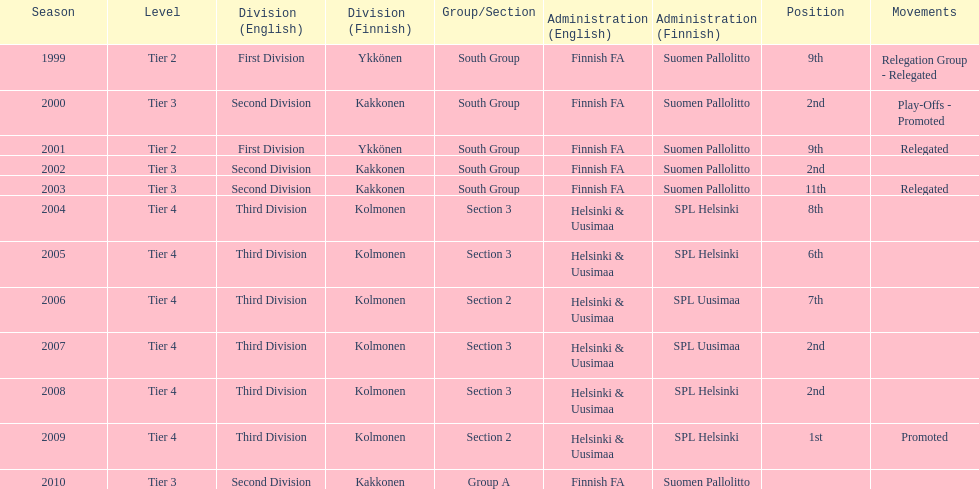Which administration has the least amount of division? Helsinki & Uusimaa (SPL Helsinki). Could you parse the entire table as a dict? {'header': ['Season', 'Level', 'Division (English)', 'Division (Finnish)', 'Group/Section', 'Administration (English)', 'Administration (Finnish)', 'Position', 'Movements'], 'rows': [['1999', 'Tier 2', 'First Division', 'Ykkönen', 'South Group', 'Finnish FA', 'Suomen Pallolitto', '9th', 'Relegation Group - Relegated'], ['2000', 'Tier 3', 'Second Division', 'Kakkonen', 'South Group', 'Finnish FA', 'Suomen Pallolitto', '2nd', 'Play-Offs - Promoted'], ['2001', 'Tier 2', 'First Division', 'Ykkönen', 'South Group', 'Finnish FA', 'Suomen Pallolitto', '9th', 'Relegated'], ['2002', 'Tier 3', 'Second Division', 'Kakkonen', 'South Group', 'Finnish FA', 'Suomen Pallolitto', '2nd', ''], ['2003', 'Tier 3', 'Second Division', 'Kakkonen', 'South Group', 'Finnish FA', 'Suomen Pallolitto', '11th', 'Relegated'], ['2004', 'Tier 4', 'Third Division', 'Kolmonen', 'Section 3', 'Helsinki & Uusimaa', 'SPL Helsinki', '8th', ''], ['2005', 'Tier 4', 'Third Division', 'Kolmonen', 'Section 3', 'Helsinki & Uusimaa', 'SPL Helsinki', '6th', ''], ['2006', 'Tier 4', 'Third Division', 'Kolmonen', 'Section 2', 'Helsinki & Uusimaa', 'SPL Uusimaa', '7th', ''], ['2007', 'Tier 4', 'Third Division', 'Kolmonen', 'Section 3', 'Helsinki & Uusimaa', 'SPL Uusimaa', '2nd', ''], ['2008', 'Tier 4', 'Third Division', 'Kolmonen', 'Section 3', 'Helsinki & Uusimaa', 'SPL Helsinki', '2nd', ''], ['2009', 'Tier 4', 'Third Division', 'Kolmonen', 'Section 2', 'Helsinki & Uusimaa', 'SPL Helsinki', '1st', 'Promoted'], ['2010', 'Tier 3', 'Second Division', 'Kakkonen', 'Group A', 'Finnish FA', 'Suomen Pallolitto', '', '']]} 